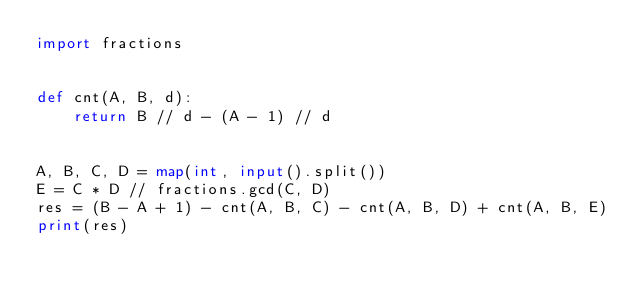Convert code to text. <code><loc_0><loc_0><loc_500><loc_500><_Python_>import fractions


def cnt(A, B, d):
    return B // d - (A - 1) // d


A, B, C, D = map(int, input().split())
E = C * D // fractions.gcd(C, D)
res = (B - A + 1) - cnt(A, B, C) - cnt(A, B, D) + cnt(A, B, E)
print(res)

</code> 